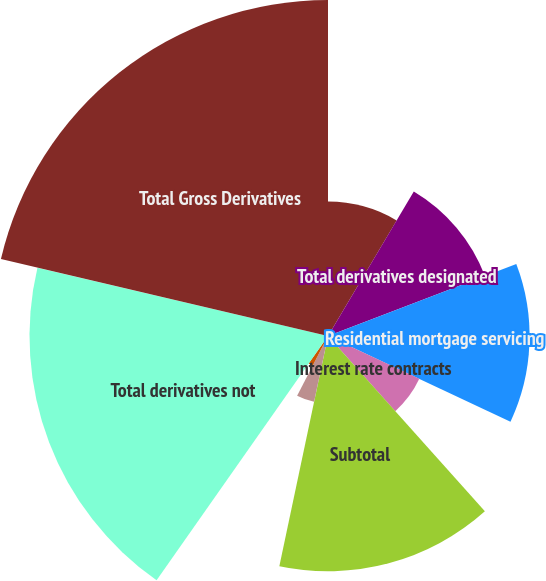Convert chart. <chart><loc_0><loc_0><loc_500><loc_500><pie_chart><fcel>Fair value hedges<fcel>Total derivatives designated<fcel>Residential mortgage servicing<fcel>Interest rate contracts<fcel>Subtotal<fcel>Foreign exchange contracts<fcel>Equity contracts<fcel>Risk participation agreements<fcel>Total derivatives not<fcel>Total Gross Derivatives<nl><fcel>8.53%<fcel>10.66%<fcel>12.79%<fcel>6.4%<fcel>14.93%<fcel>4.27%<fcel>0.01%<fcel>2.14%<fcel>18.94%<fcel>21.32%<nl></chart> 